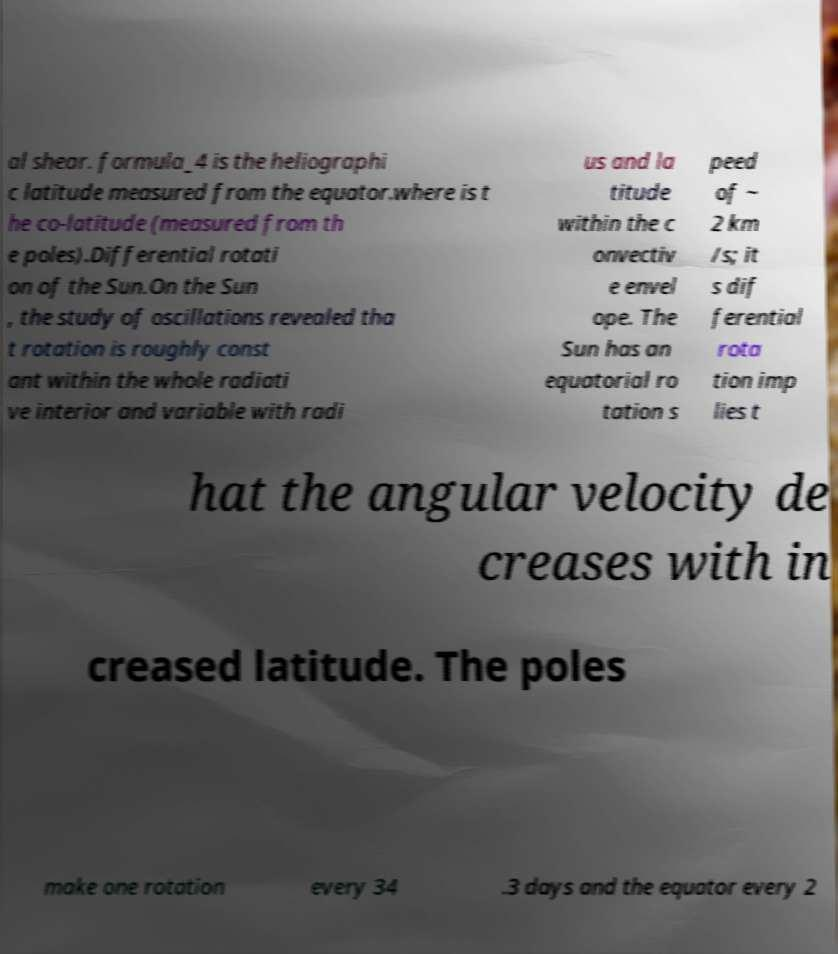There's text embedded in this image that I need extracted. Can you transcribe it verbatim? al shear. formula_4 is the heliographi c latitude measured from the equator.where is t he co-latitude (measured from th e poles).Differential rotati on of the Sun.On the Sun , the study of oscillations revealed tha t rotation is roughly const ant within the whole radiati ve interior and variable with radi us and la titude within the c onvectiv e envel ope. The Sun has an equatorial ro tation s peed of ~ 2 km /s; it s dif ferential rota tion imp lies t hat the angular velocity de creases with in creased latitude. The poles make one rotation every 34 .3 days and the equator every 2 